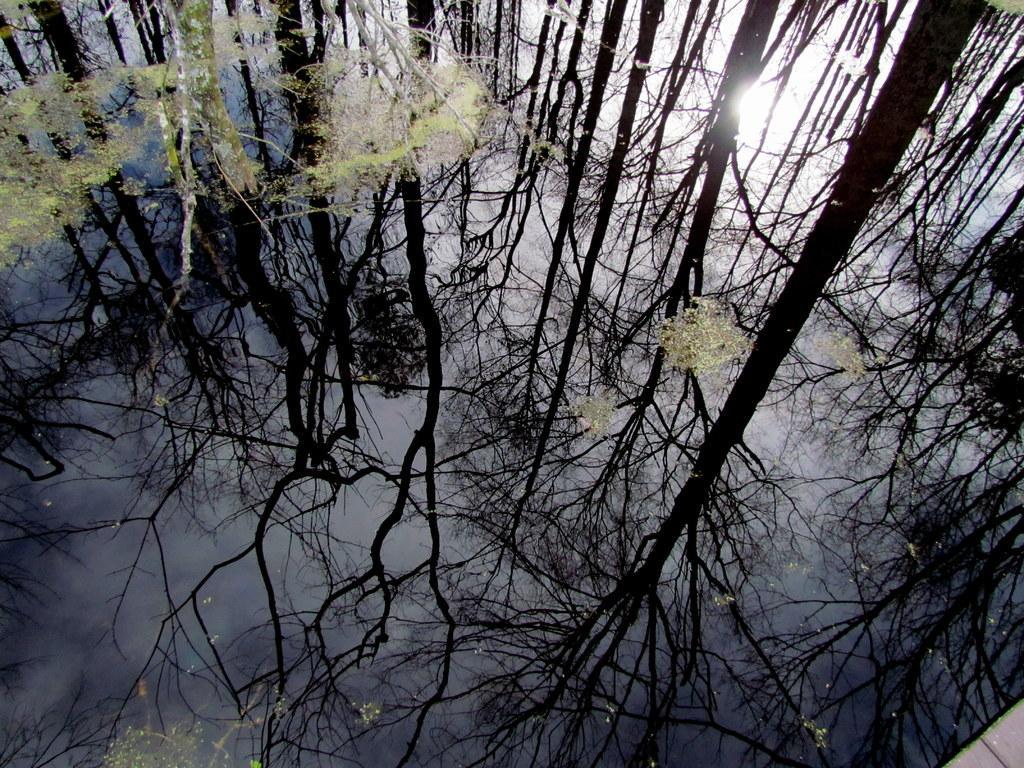Describe this image in one or two sentences. In this image, we can see some water with some objects floating on it. We can see the reflection of trees and the sky in the water. 